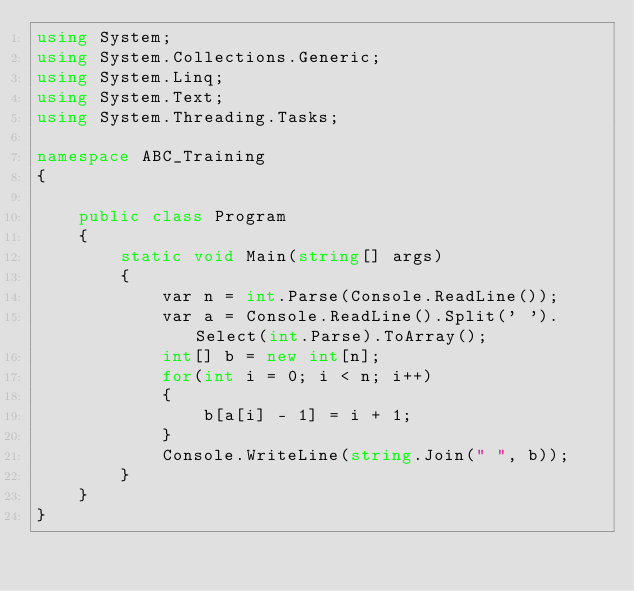<code> <loc_0><loc_0><loc_500><loc_500><_C#_>using System;
using System.Collections.Generic;
using System.Linq;
using System.Text;
using System.Threading.Tasks;

namespace ABC_Training
{

    public class Program
    {
        static void Main(string[] args)
        {
            var n = int.Parse(Console.ReadLine());
            var a = Console.ReadLine().Split(' ').Select(int.Parse).ToArray();
            int[] b = new int[n];
            for(int i = 0; i < n; i++)
            {
                b[a[i] - 1] = i + 1;
            }
            Console.WriteLine(string.Join(" ", b));
        }
    }
}
</code> 